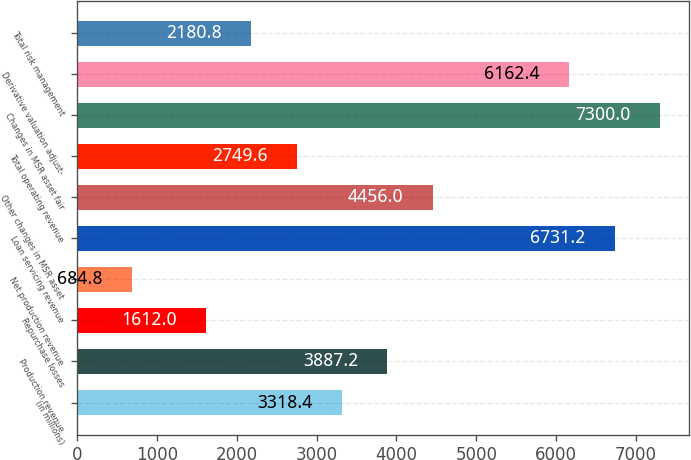Convert chart to OTSL. <chart><loc_0><loc_0><loc_500><loc_500><bar_chart><fcel>(in millions)<fcel>Production revenue<fcel>Repurchase losses<fcel>Net production revenue<fcel>Loan servicing revenue<fcel>Other changes in MSR asset<fcel>Total operating revenue<fcel>Changes in MSR asset fair<fcel>Derivative valuation adjust-<fcel>Total risk management<nl><fcel>3318.4<fcel>3887.2<fcel>1612<fcel>684.8<fcel>6731.2<fcel>4456<fcel>2749.6<fcel>7300<fcel>6162.4<fcel>2180.8<nl></chart> 